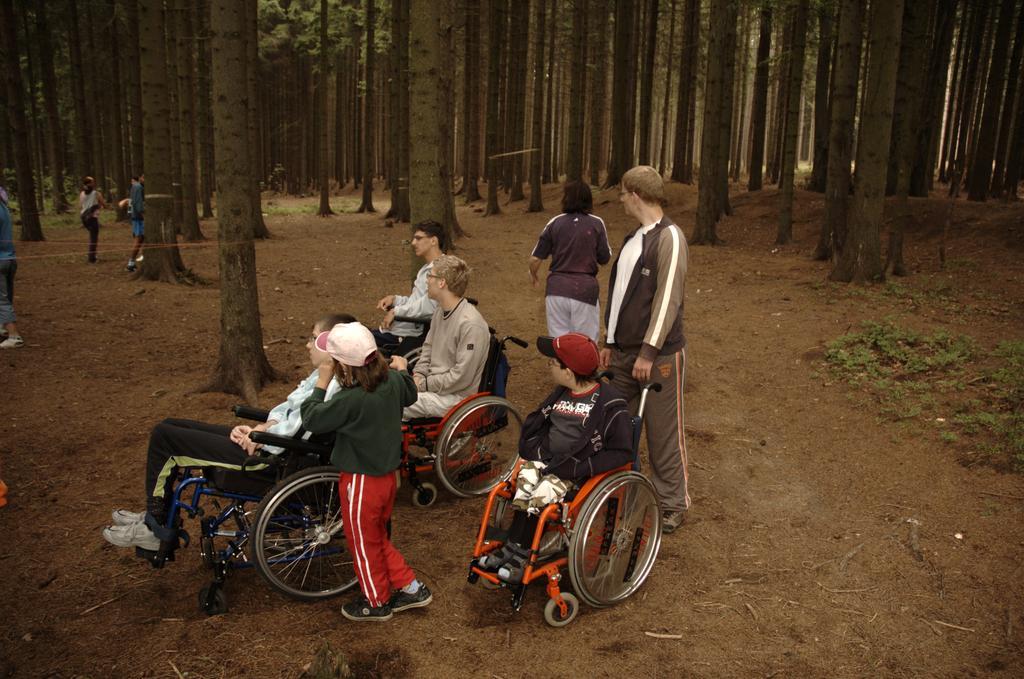Can you describe this image briefly? In this image we can see some persons standing on the ground and some are sitting in the wheel chairs. In the background there are trees and grass. 